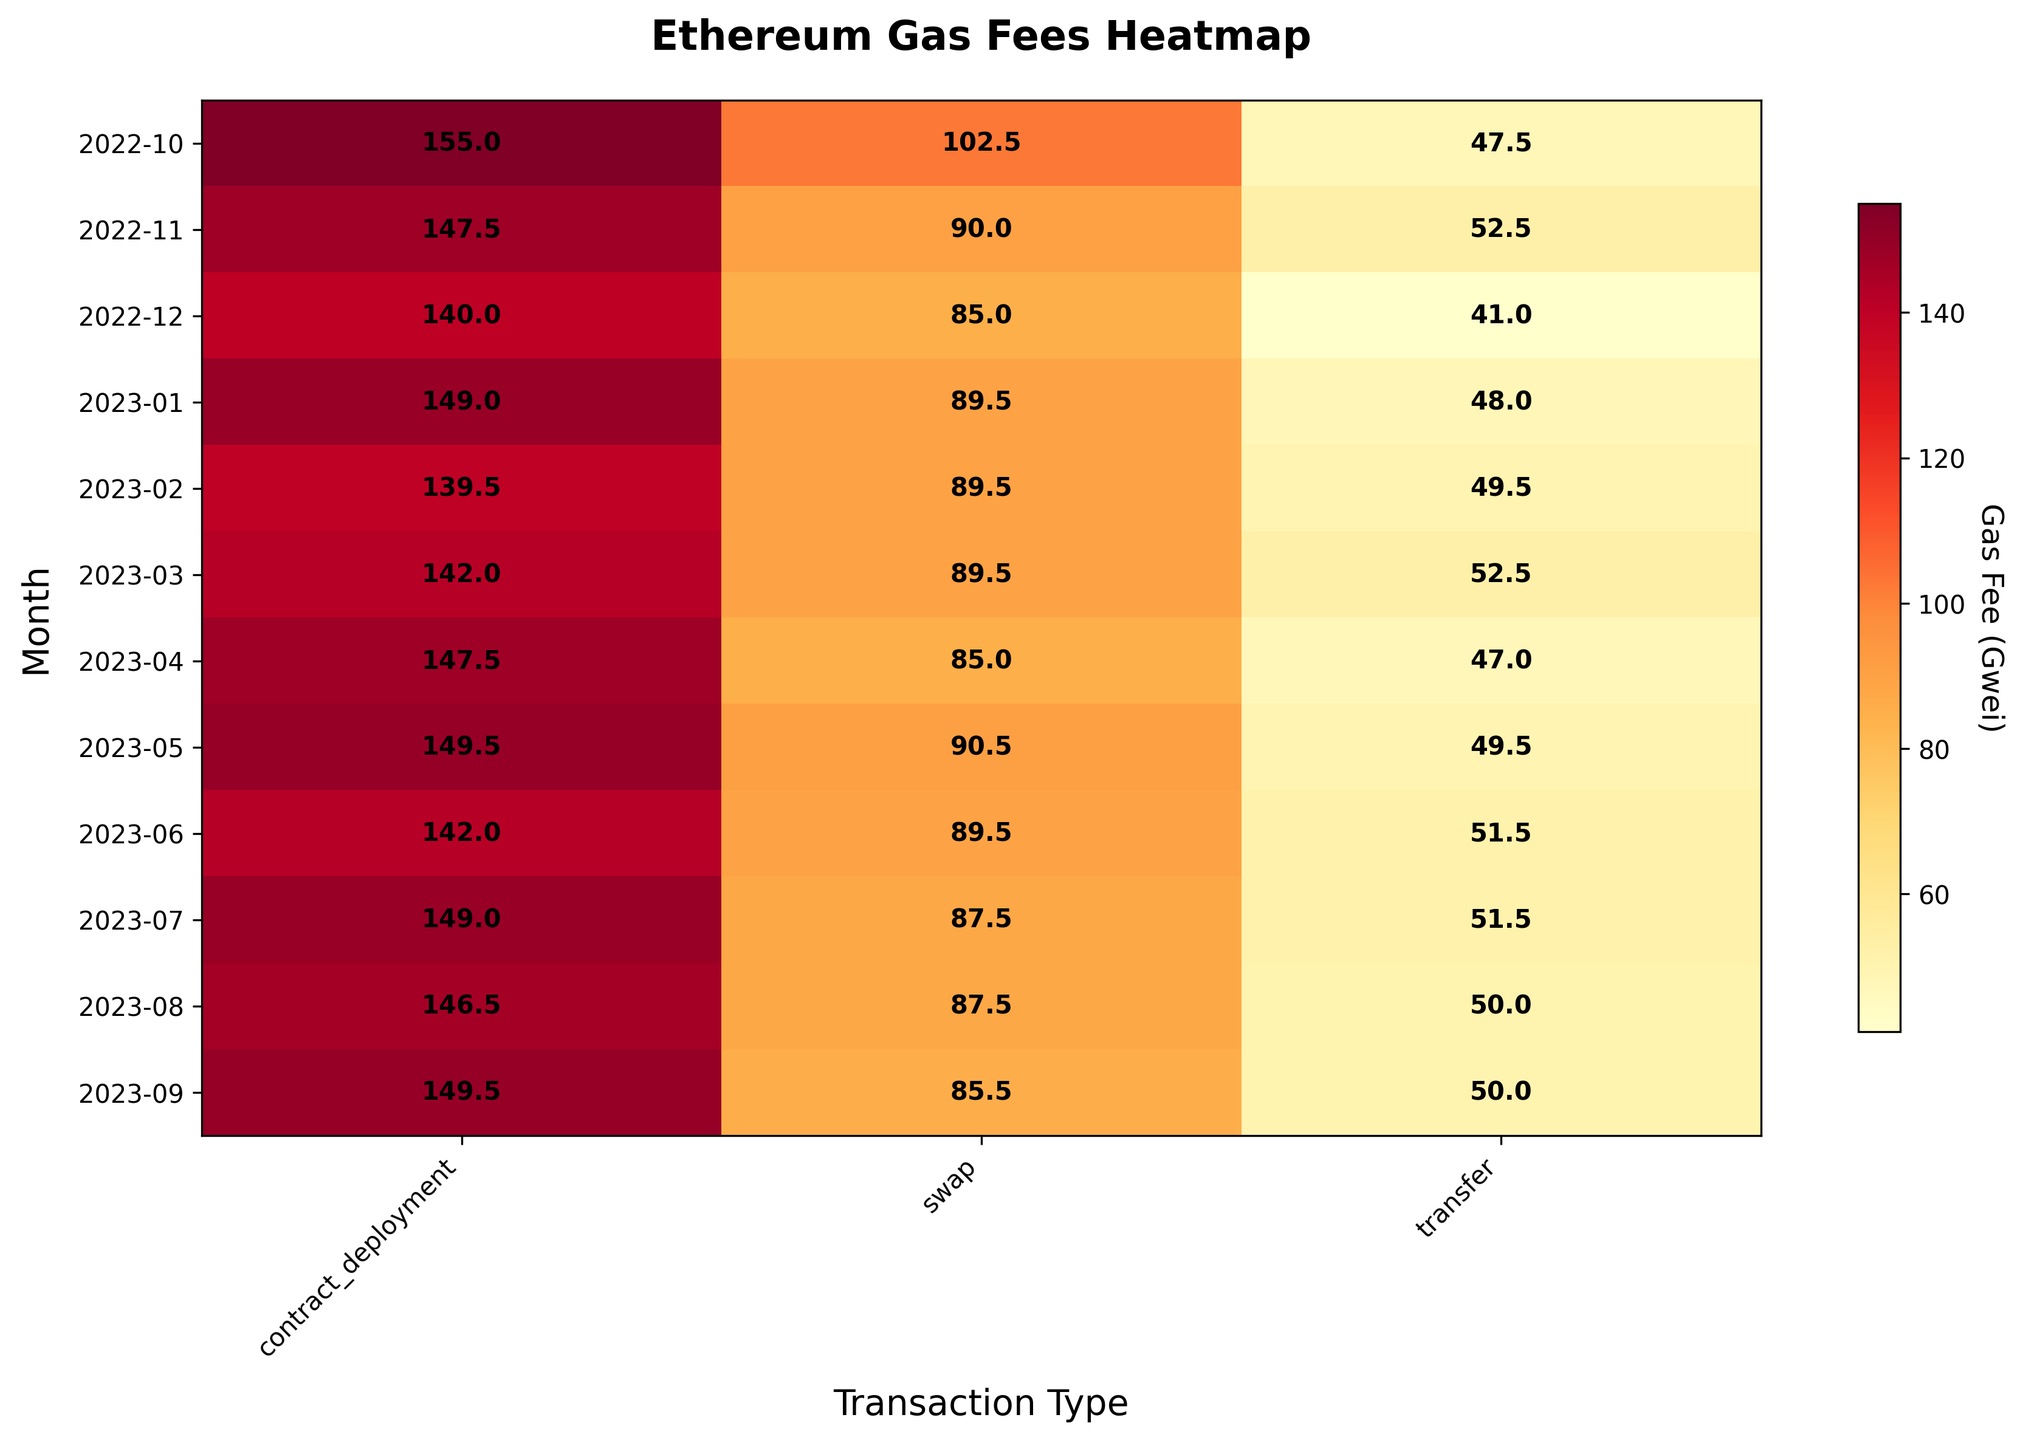What's the title of the heatmap? The title is clearly written at the top center of the heatmap in bold font. It reads "Ethereum Gas Fees Heatmap".
Answer: Ethereum Gas Fees Heatmap Which transaction type has the highest average gas fee in March 2023? In March 2023 row, the highest value is present under the "contract_deployment" column, which shows an average gas fee of 144.0 Gwei.
Answer: contract_deployment What is the average gas fee for "swap" transactions in June 2023? First find the June 2023 row and then the "swap" column. The value there is 89.5, which is the average gas fee for "swap" transactions in June 2023.
Answer: 89.5 Gwei Which month had the lowest average gas fee for "transfer" transactions? By scanning through the "transfer" column, the smallest value is found in December 2022, which is 41.0 Gwei.
Answer: December 2022 What is the difference in average gas fee between "contract_deployment" and "swap" transactions in April 2023? In the April 2023 row, the values for "contract_deployment" and "swap" are 145.0 and 85.0 respectively. The difference is calculated as 145.0 - 85.0 = 60 Gwei.
Answer: 60 Gwei Which transaction type generally incurs the highest gas fees overall? By visually inspecting the heat intensity across columns, the "contract_deployment" column consistently has higher value shades compared to "transfer" and "swap" transactions, indicating higher gas fees.
Answer: contract_deployment What's the overall trend of gas fees for "transfer" transactions over the year? The "transfer" column shows that gas fees vary but generally remain within the 40 to 55 Gwei range, showing a relatively stable pattern without any sharp increases or decreases.
Answer: Stable within 40-55 Gwei Which month had the widest range of average gas fees across all transaction types? By comparing the maximum and minimum values across rows, May 2022 shows a range from 47.0 Gwei in "transfer" to 152.0 Gwei in "contract_deployment". The range is 152.0 - 47.0 = 105 Gwei, the largest observed range.
Answer: May 2022 In which month were the gas fees for all transaction types closest to each other? In April 2023, all values are close with "transfer" at 48.0, "contract_deployment" at 145.0, and "swap" at 85.0. The range difference is smaller compared to other months.
Answer: April 2023 